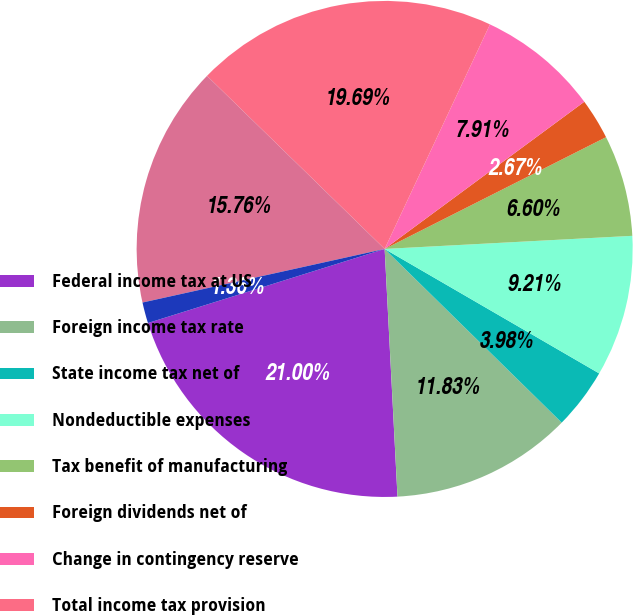Convert chart to OTSL. <chart><loc_0><loc_0><loc_500><loc_500><pie_chart><fcel>Federal income tax at US<fcel>Foreign income tax rate<fcel>State income tax net of<fcel>Nondeductible expenses<fcel>Tax benefit of manufacturing<fcel>Foreign dividends net of<fcel>Change in contingency reserve<fcel>Total income tax provision<fcel>Allowances and operating<fcel>Net operating loss<nl><fcel>21.0%<fcel>11.83%<fcel>3.98%<fcel>9.21%<fcel>6.6%<fcel>2.67%<fcel>7.91%<fcel>19.69%<fcel>15.76%<fcel>1.36%<nl></chart> 